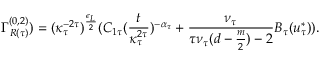Convert formula to latex. <formula><loc_0><loc_0><loc_500><loc_500>\Gamma _ { R ( \tau ) } ^ { ( 0 , 2 ) } ) = ( \kappa _ { \tau } ^ { - 2 \tau } ) ^ { \frac { \epsilon _ { L } } { 2 } } ( C _ { 1 \tau } ( \frac { t } { \kappa _ { \tau } ^ { 2 \tau } } ) ^ { - \alpha _ { \tau } } + \frac { \nu _ { \tau } } { \tau \nu _ { \tau } ( d - \frac { m } { 2 } ) - 2 } B _ { \tau } ( u _ { \tau } ^ { * } ) ) .</formula> 